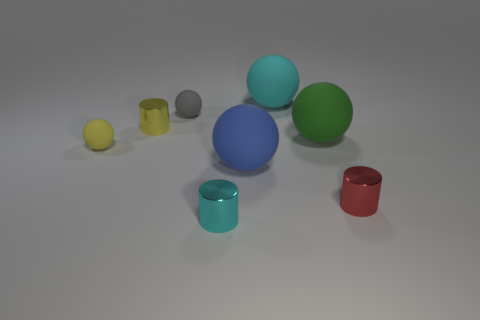Subtract all gray spheres. How many spheres are left? 4 Subtract all yellow rubber spheres. How many spheres are left? 4 Subtract all green balls. Subtract all gray cubes. How many balls are left? 4 Add 1 tiny brown objects. How many objects exist? 9 Subtract all cylinders. How many objects are left? 5 Add 8 small red things. How many small red things exist? 9 Subtract 1 red cylinders. How many objects are left? 7 Subtract all big gray spheres. Subtract all green matte spheres. How many objects are left? 7 Add 1 large blue rubber things. How many large blue rubber things are left? 2 